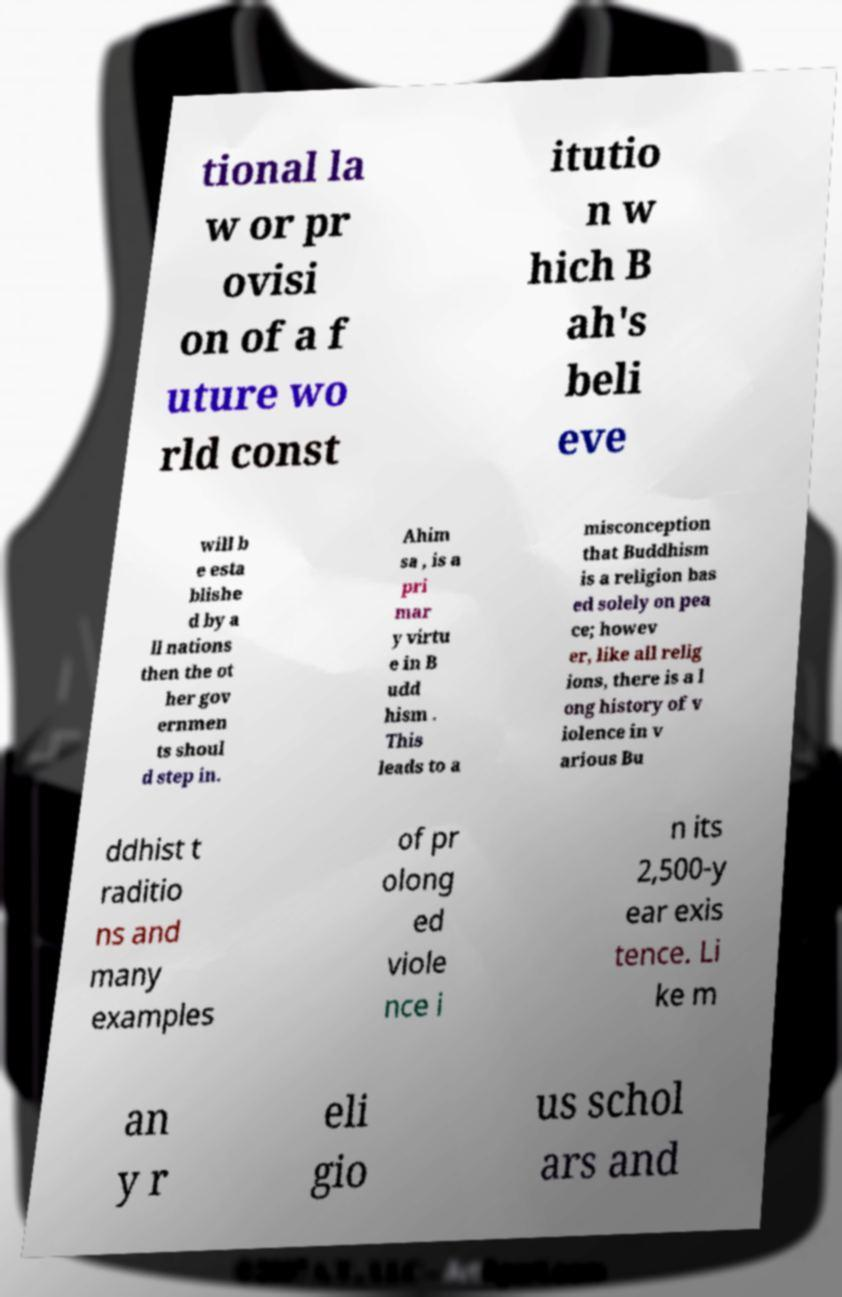There's text embedded in this image that I need extracted. Can you transcribe it verbatim? tional la w or pr ovisi on of a f uture wo rld const itutio n w hich B ah's beli eve will b e esta blishe d by a ll nations then the ot her gov ernmen ts shoul d step in. Ahim sa , is a pri mar y virtu e in B udd hism . This leads to a misconception that Buddhism is a religion bas ed solely on pea ce; howev er, like all relig ions, there is a l ong history of v iolence in v arious Bu ddhist t raditio ns and many examples of pr olong ed viole nce i n its 2,500-y ear exis tence. Li ke m an y r eli gio us schol ars and 